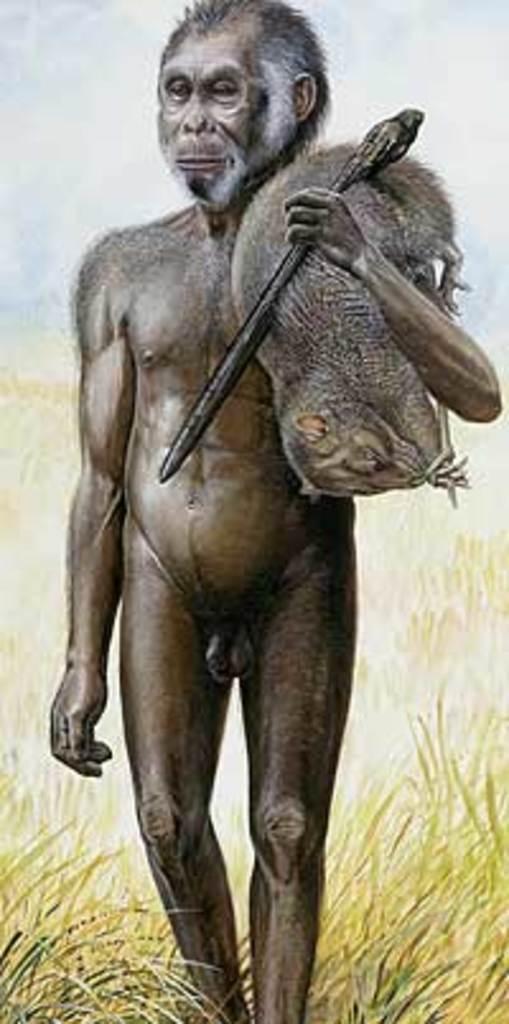Describe this image in one or two sentences. In this image we can see the statue of an early man holding an animal and a stick. At the bottom of the image there is the grass. In the background of the image there is the sky. 